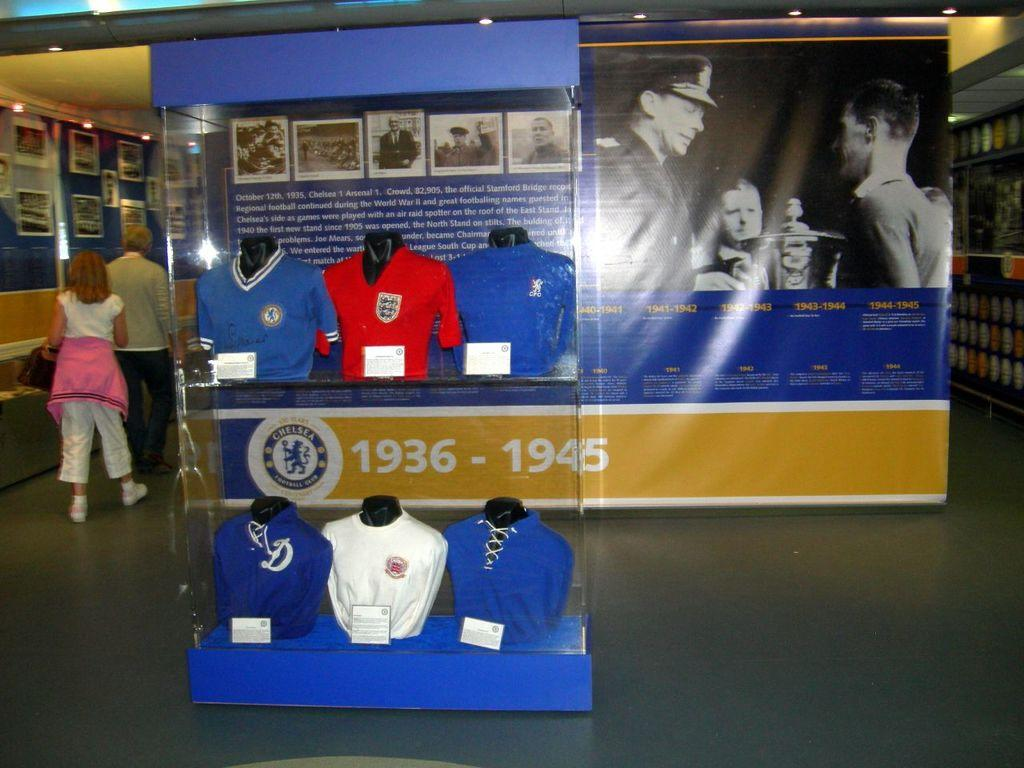<image>
Give a short and clear explanation of the subsequent image. A display with shirts in it is also dated 1936-1945. 